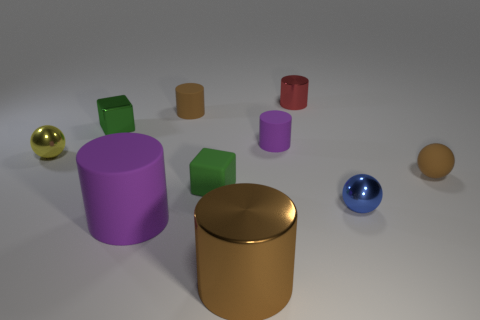Is the number of matte cylinders greater than the number of metal things?
Offer a terse response. No. The brown object that is made of the same material as the tiny yellow thing is what size?
Make the answer very short. Large. There is a blue object that is to the right of the red cylinder; is it the same size as the purple rubber object that is in front of the brown ball?
Your answer should be very brief. No. What number of things are matte cylinders that are in front of the small green rubber object or purple shiny balls?
Keep it short and to the point. 1. Are there fewer red rubber blocks than red metallic cylinders?
Give a very brief answer. Yes. There is a large thing that is to the left of the brown thing behind the sphere to the left of the big metal object; what is its shape?
Give a very brief answer. Cylinder. There is a rubber thing that is the same color as the big matte cylinder; what shape is it?
Offer a very short reply. Cylinder. Is there a blue cylinder?
Offer a very short reply. No. There is a brown metallic object; is it the same size as the purple thing that is in front of the blue metal ball?
Offer a terse response. Yes. Is there a big shiny thing that is behind the purple rubber object behind the tiny blue object?
Provide a succinct answer. No. 